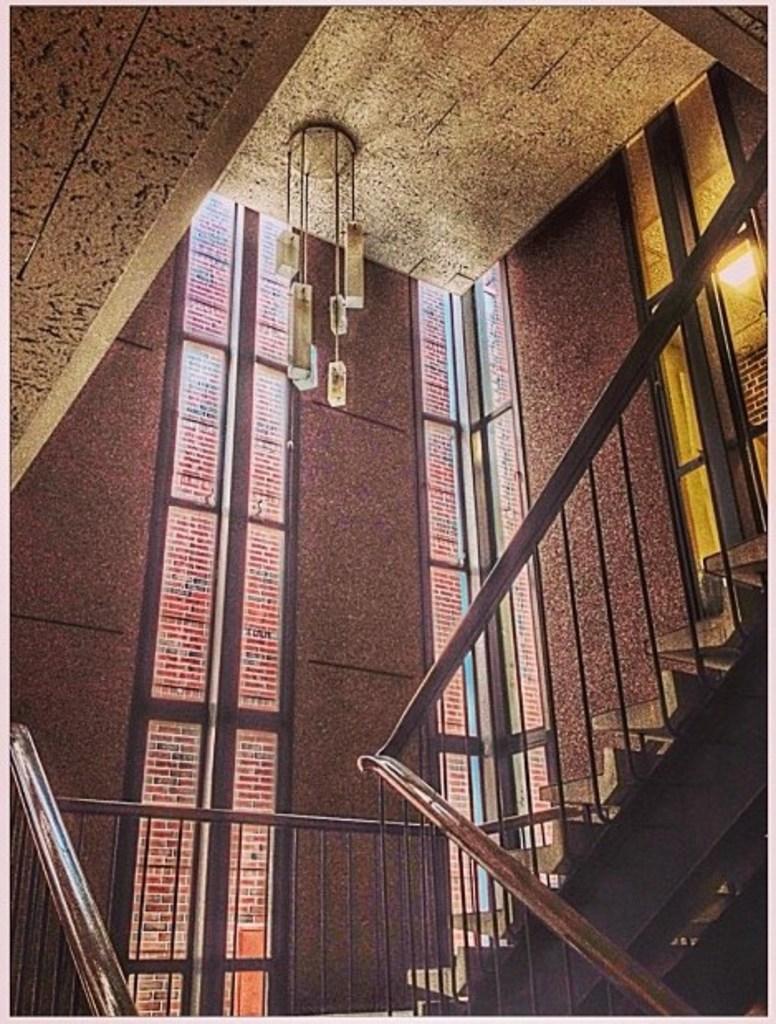Could you give a brief overview of what you see in this image? In this image we can see an inside view of a building. to the right side, we can see a staircase and metal railing, a chandelier on the roof. In the background, we can see the windows and lights. 